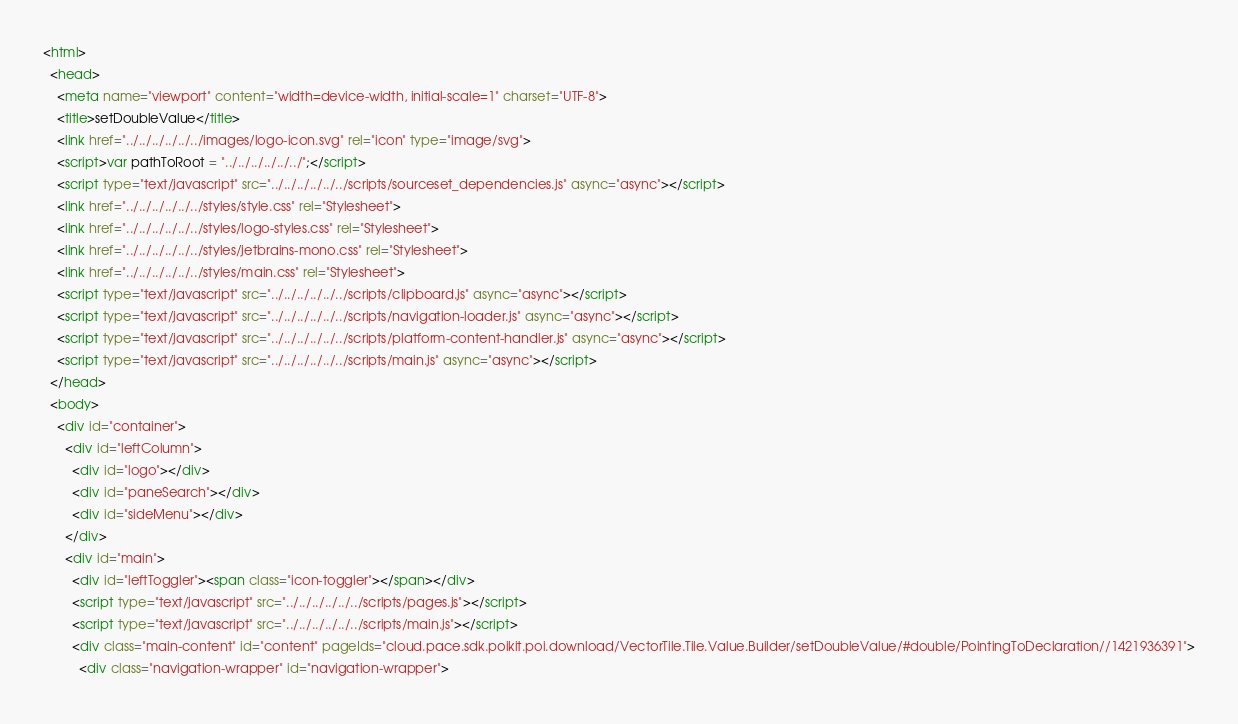Convert code to text. <code><loc_0><loc_0><loc_500><loc_500><_HTML_><html>
  <head>
    <meta name="viewport" content="width=device-width, initial-scale=1" charset="UTF-8">
    <title>setDoubleValue</title>
    <link href="../../../../../../images/logo-icon.svg" rel="icon" type="image/svg">
    <script>var pathToRoot = "../../../../../../";</script>
    <script type="text/javascript" src="../../../../../../scripts/sourceset_dependencies.js" async="async"></script>
    <link href="../../../../../../styles/style.css" rel="Stylesheet">
    <link href="../../../../../../styles/logo-styles.css" rel="Stylesheet">
    <link href="../../../../../../styles/jetbrains-mono.css" rel="Stylesheet">
    <link href="../../../../../../styles/main.css" rel="Stylesheet">
    <script type="text/javascript" src="../../../../../../scripts/clipboard.js" async="async"></script>
    <script type="text/javascript" src="../../../../../../scripts/navigation-loader.js" async="async"></script>
    <script type="text/javascript" src="../../../../../../scripts/platform-content-handler.js" async="async"></script>
    <script type="text/javascript" src="../../../../../../scripts/main.js" async="async"></script>
  </head>
  <body>
    <div id="container">
      <div id="leftColumn">
        <div id="logo"></div>
        <div id="paneSearch"></div>
        <div id="sideMenu"></div>
      </div>
      <div id="main">
        <div id="leftToggler"><span class="icon-toggler"></span></div>
        <script type="text/javascript" src="../../../../../../scripts/pages.js"></script>
        <script type="text/javascript" src="../../../../../../scripts/main.js"></script>
        <div class="main-content" id="content" pageIds="cloud.pace.sdk.poikit.poi.download/VectorTile.Tile.Value.Builder/setDoubleValue/#double/PointingToDeclaration//1421936391">
          <div class="navigation-wrapper" id="navigation-wrapper"></code> 